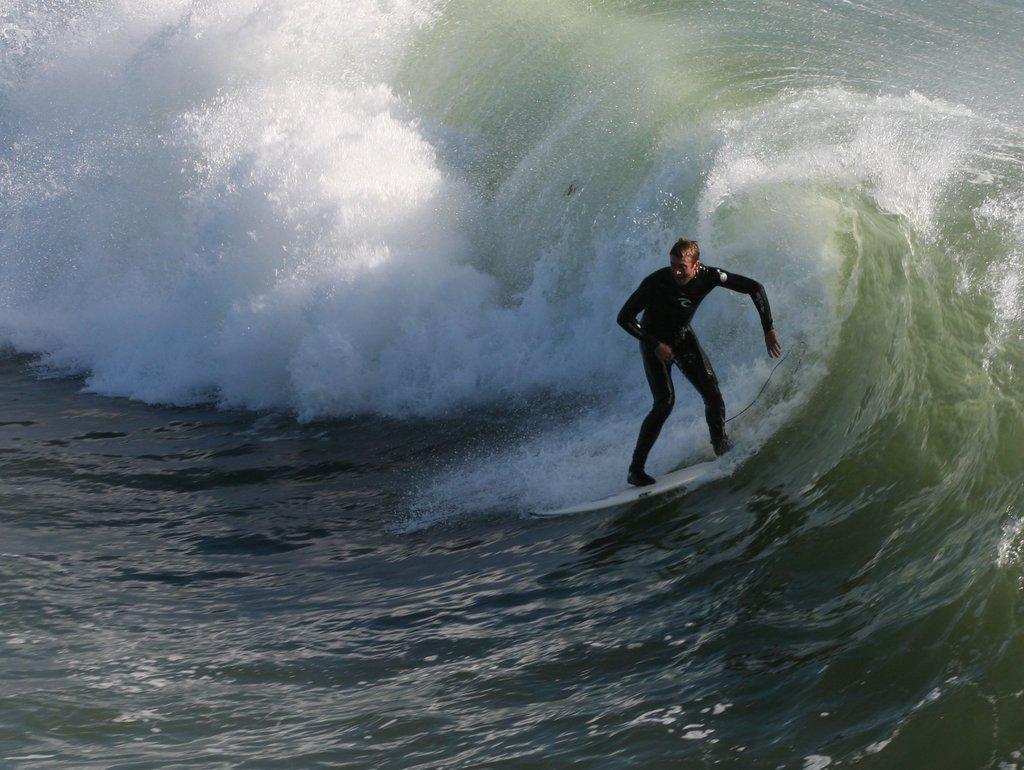In one or two sentences, can you explain what this image depicts? Here we can see a man surfing on the surfboard on the water. 